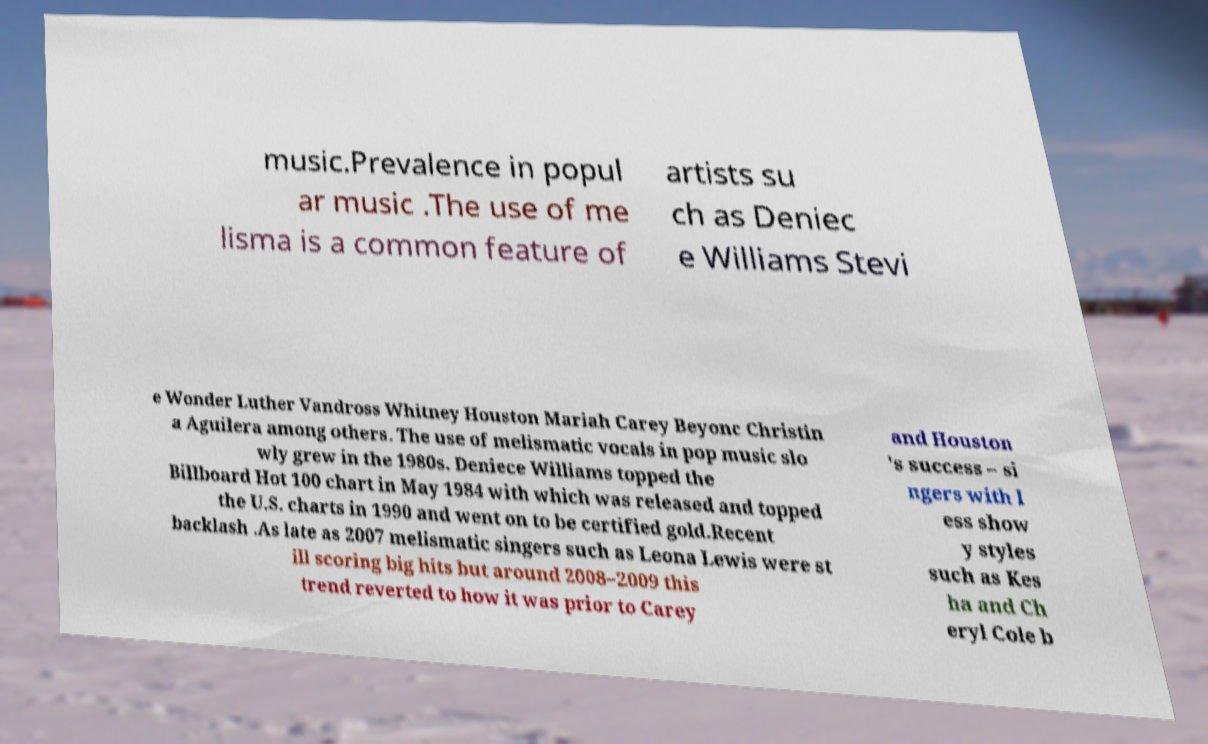Could you extract and type out the text from this image? music.Prevalence in popul ar music .The use of me lisma is a common feature of artists su ch as Deniec e Williams Stevi e Wonder Luther Vandross Whitney Houston Mariah Carey Beyonc Christin a Aguilera among others. The use of melismatic vocals in pop music slo wly grew in the 1980s. Deniece Williams topped the Billboard Hot 100 chart in May 1984 with which was released and topped the U.S. charts in 1990 and went on to be certified gold.Recent backlash .As late as 2007 melismatic singers such as Leona Lewis were st ill scoring big hits but around 2008–2009 this trend reverted to how it was prior to Carey and Houston 's success – si ngers with l ess show y styles such as Kes ha and Ch eryl Cole b 